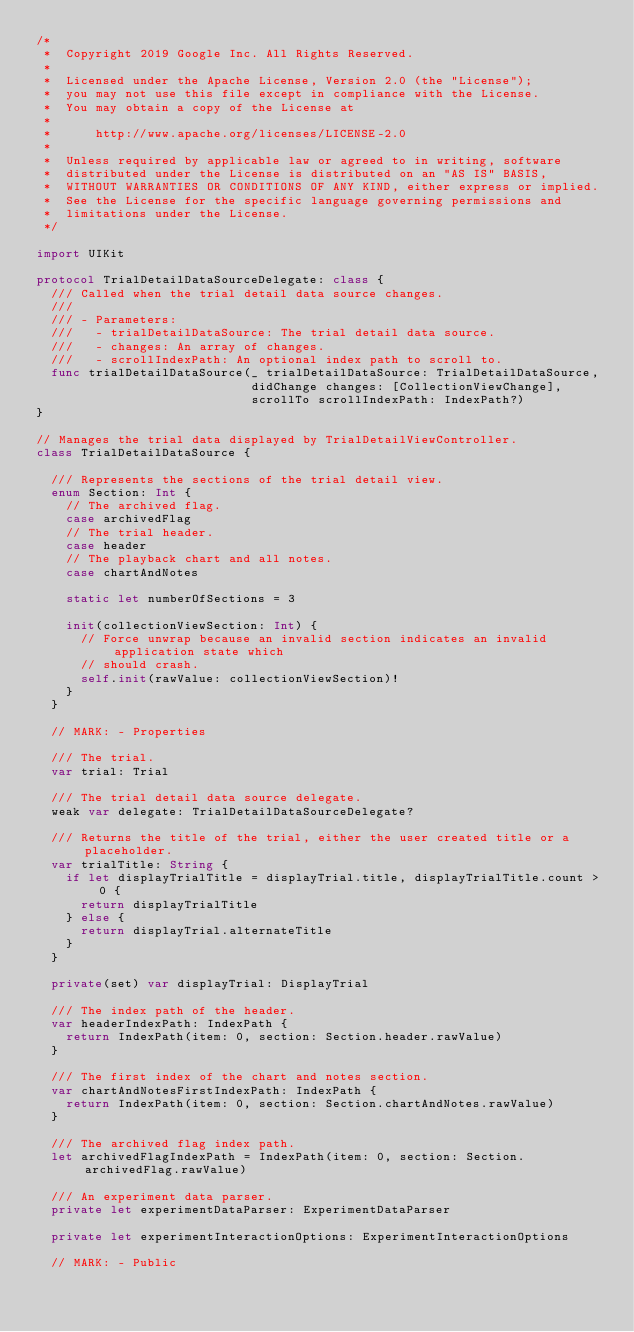<code> <loc_0><loc_0><loc_500><loc_500><_Swift_>/*
 *  Copyright 2019 Google Inc. All Rights Reserved.
 *
 *  Licensed under the Apache License, Version 2.0 (the "License");
 *  you may not use this file except in compliance with the License.
 *  You may obtain a copy of the License at
 *
 *      http://www.apache.org/licenses/LICENSE-2.0
 *
 *  Unless required by applicable law or agreed to in writing, software
 *  distributed under the License is distributed on an "AS IS" BASIS,
 *  WITHOUT WARRANTIES OR CONDITIONS OF ANY KIND, either express or implied.
 *  See the License for the specific language governing permissions and
 *  limitations under the License.
 */

import UIKit

protocol TrialDetailDataSourceDelegate: class {
  /// Called when the trial detail data source changes.
  ///
  /// - Parameters:
  ///   - trialDetailDataSource: The trial detail data source.
  ///   - changes: An array of changes.
  ///   - scrollIndexPath: An optional index path to scroll to.
  func trialDetailDataSource(_ trialDetailDataSource: TrialDetailDataSource,
                             didChange changes: [CollectionViewChange],
                             scrollTo scrollIndexPath: IndexPath?)
}

// Manages the trial data displayed by TrialDetailViewController.
class TrialDetailDataSource {

  /// Represents the sections of the trial detail view.
  enum Section: Int {
    // The archived flag.
    case archivedFlag
    // The trial header.
    case header
    // The playback chart and all notes.
    case chartAndNotes

    static let numberOfSections = 3

    init(collectionViewSection: Int) {
      // Force unwrap because an invalid section indicates an invalid application state which
      // should crash.
      self.init(rawValue: collectionViewSection)!
    }
  }

  // MARK: - Properties

  /// The trial.
  var trial: Trial

  /// The trial detail data source delegate.
  weak var delegate: TrialDetailDataSourceDelegate?

  /// Returns the title of the trial, either the user created title or a placeholder.
  var trialTitle: String {
    if let displayTrialTitle = displayTrial.title, displayTrialTitle.count > 0 {
      return displayTrialTitle
    } else {
      return displayTrial.alternateTitle
    }
  }

  private(set) var displayTrial: DisplayTrial

  /// The index path of the header.
  var headerIndexPath: IndexPath {
    return IndexPath(item: 0, section: Section.header.rawValue)
  }

  /// The first index of the chart and notes section.
  var chartAndNotesFirstIndexPath: IndexPath {
    return IndexPath(item: 0, section: Section.chartAndNotes.rawValue)
  }

  /// The archived flag index path.
  let archivedFlagIndexPath = IndexPath(item: 0, section: Section.archivedFlag.rawValue)

  /// An experiment data parser.
  private let experimentDataParser: ExperimentDataParser

  private let experimentInteractionOptions: ExperimentInteractionOptions

  // MARK: - Public
</code> 